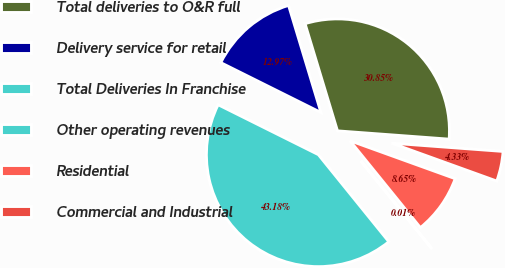<chart> <loc_0><loc_0><loc_500><loc_500><pie_chart><fcel>Total deliveries to O&R full<fcel>Delivery service for retail<fcel>Total Deliveries In Franchise<fcel>Other operating revenues<fcel>Residential<fcel>Commercial and Industrial<nl><fcel>30.85%<fcel>12.97%<fcel>43.18%<fcel>0.01%<fcel>8.65%<fcel>4.33%<nl></chart> 